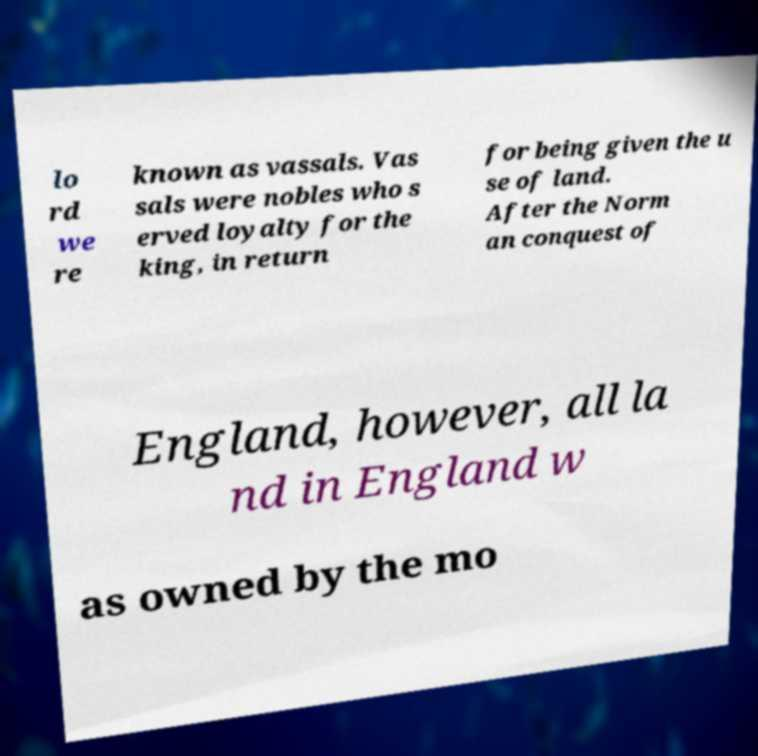What messages or text are displayed in this image? I need them in a readable, typed format. lo rd we re known as vassals. Vas sals were nobles who s erved loyalty for the king, in return for being given the u se of land. After the Norm an conquest of England, however, all la nd in England w as owned by the mo 